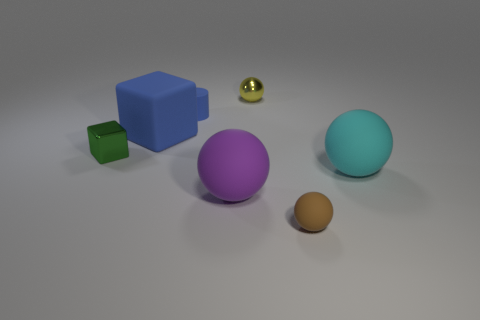There is a object that is behind the large blue rubber block and to the right of the purple rubber object; what is its size?
Your answer should be very brief. Small. There is a large blue thing that is the same shape as the small green object; what is its material?
Provide a succinct answer. Rubber. There is a sphere that is behind the cyan thing; is it the same size as the big cyan thing?
Ensure brevity in your answer.  No. What is the color of the small thing that is both on the left side of the tiny metal ball and behind the matte cube?
Offer a terse response. Blue. What number of green metallic cubes are right of the blue matte object that is right of the blue block?
Provide a short and direct response. 0. Do the small green metal object and the small blue rubber thing have the same shape?
Your answer should be compact. No. Is there anything else that is the same color as the metallic block?
Provide a succinct answer. No. Does the cyan object have the same shape as the large rubber object that is on the left side of the small rubber cylinder?
Your answer should be compact. No. What color is the big matte thing that is behind the metal block in front of the block behind the green object?
Your response must be concise. Blue. Are there any other things that are the same material as the small brown thing?
Offer a very short reply. Yes. 